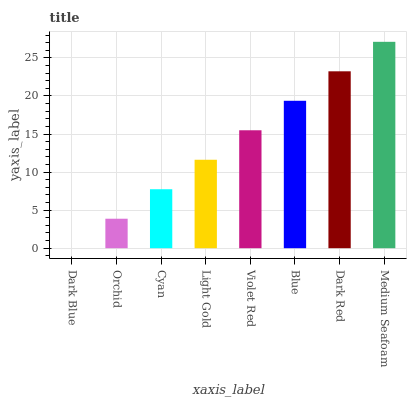Is Dark Blue the minimum?
Answer yes or no. Yes. Is Medium Seafoam the maximum?
Answer yes or no. Yes. Is Orchid the minimum?
Answer yes or no. No. Is Orchid the maximum?
Answer yes or no. No. Is Orchid greater than Dark Blue?
Answer yes or no. Yes. Is Dark Blue less than Orchid?
Answer yes or no. Yes. Is Dark Blue greater than Orchid?
Answer yes or no. No. Is Orchid less than Dark Blue?
Answer yes or no. No. Is Violet Red the high median?
Answer yes or no. Yes. Is Light Gold the low median?
Answer yes or no. Yes. Is Dark Red the high median?
Answer yes or no. No. Is Cyan the low median?
Answer yes or no. No. 